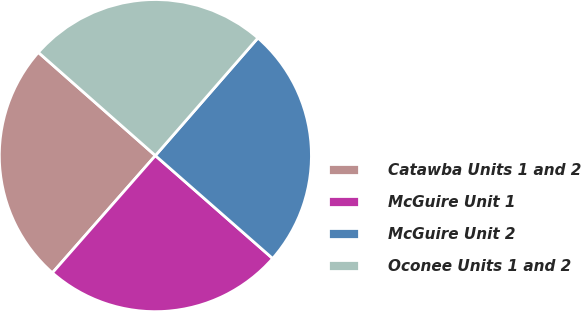Convert chart to OTSL. <chart><loc_0><loc_0><loc_500><loc_500><pie_chart><fcel>Catawba Units 1 and 2<fcel>McGuire Unit 1<fcel>McGuire Unit 2<fcel>Oconee Units 1 and 2<nl><fcel>25.03%<fcel>25.01%<fcel>25.05%<fcel>24.91%<nl></chart> 